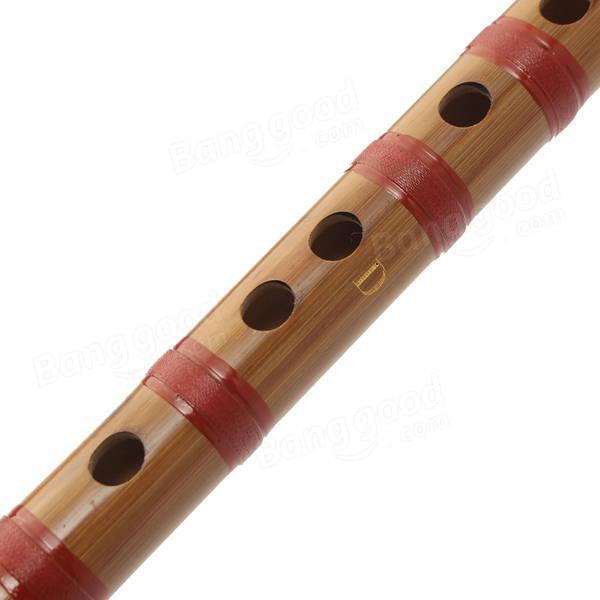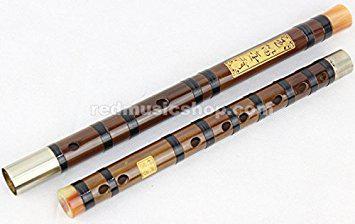The first image is the image on the left, the second image is the image on the right. For the images displayed, is the sentence "One image shows two diagonally displayed, side-by-side wooden flutes, and the other image shows at least one hole in a single wooden flute." factually correct? Answer yes or no. Yes. The first image is the image on the left, the second image is the image on the right. Analyze the images presented: Is the assertion "There are two flutes in the left image." valid? Answer yes or no. No. 